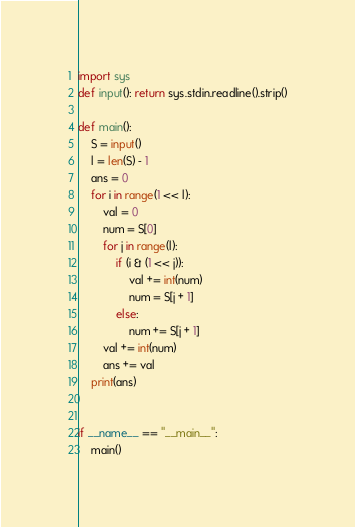<code> <loc_0><loc_0><loc_500><loc_500><_Python_>import sys
def input(): return sys.stdin.readline().strip()

def main():
    S = input()
    l = len(S) - 1
    ans = 0
    for i in range(1 << l):
        val = 0
        num = S[0]
        for j in range(l):
            if (i & (1 << j)):
                val += int(num)
                num = S[j + 1]
            else:
                num += S[j + 1]
        val += int(num)
        ans += val
    print(ans)


if __name__ == "__main__":
    main()
</code> 